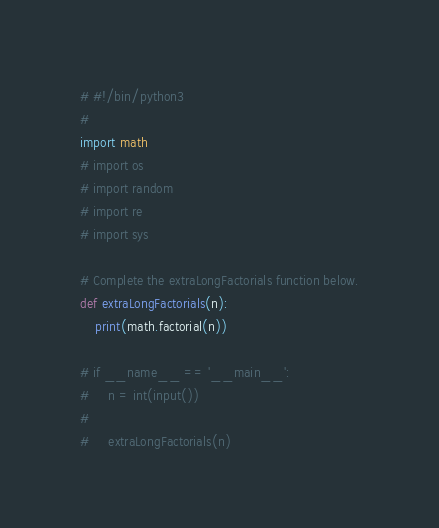Convert code to text. <code><loc_0><loc_0><loc_500><loc_500><_Python_># #!/bin/python3
#
import math
# import os
# import random
# import re
# import sys

# Complete the extraLongFactorials function below.
def extraLongFactorials(n):
    print(math.factorial(n))

# if __name__ == '__main__':
#     n = int(input())
#
#     extraLongFactorials(n)
</code> 